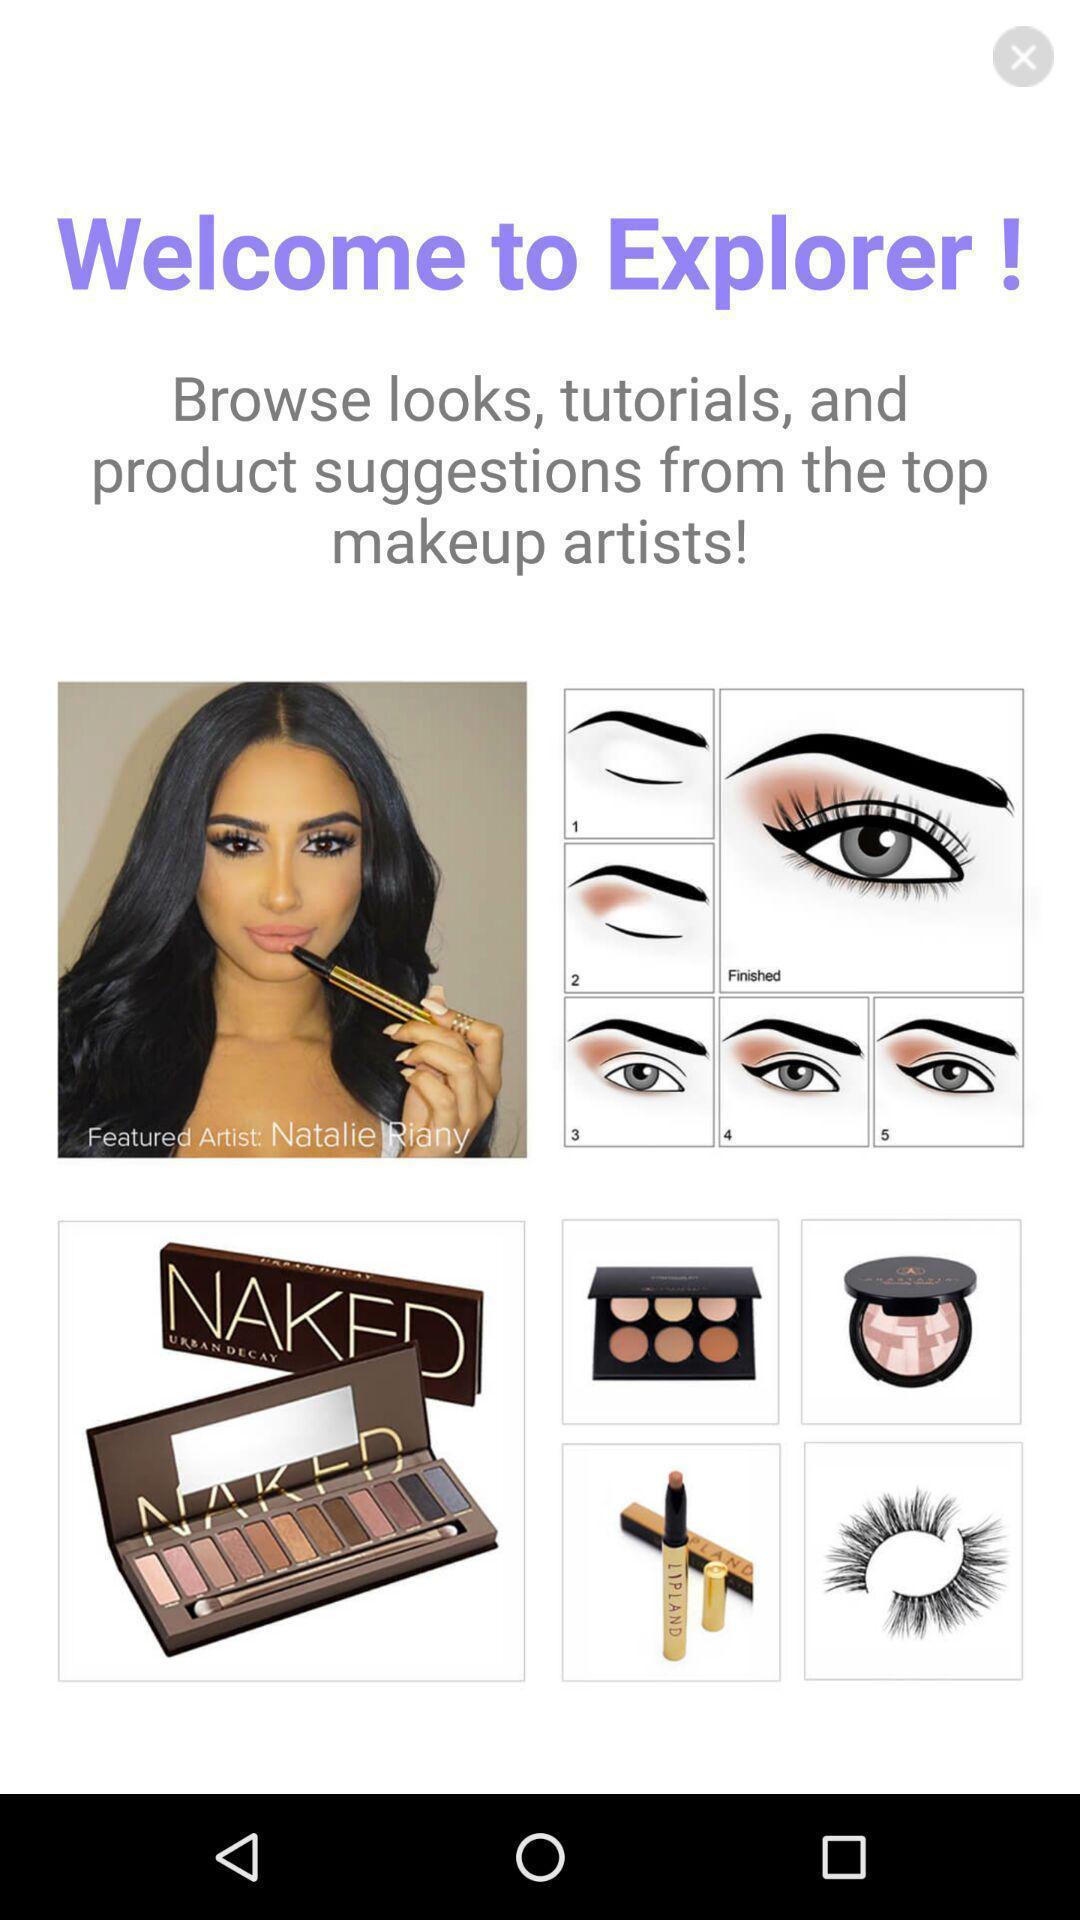Summarize the main components in this picture. Welcome page. 